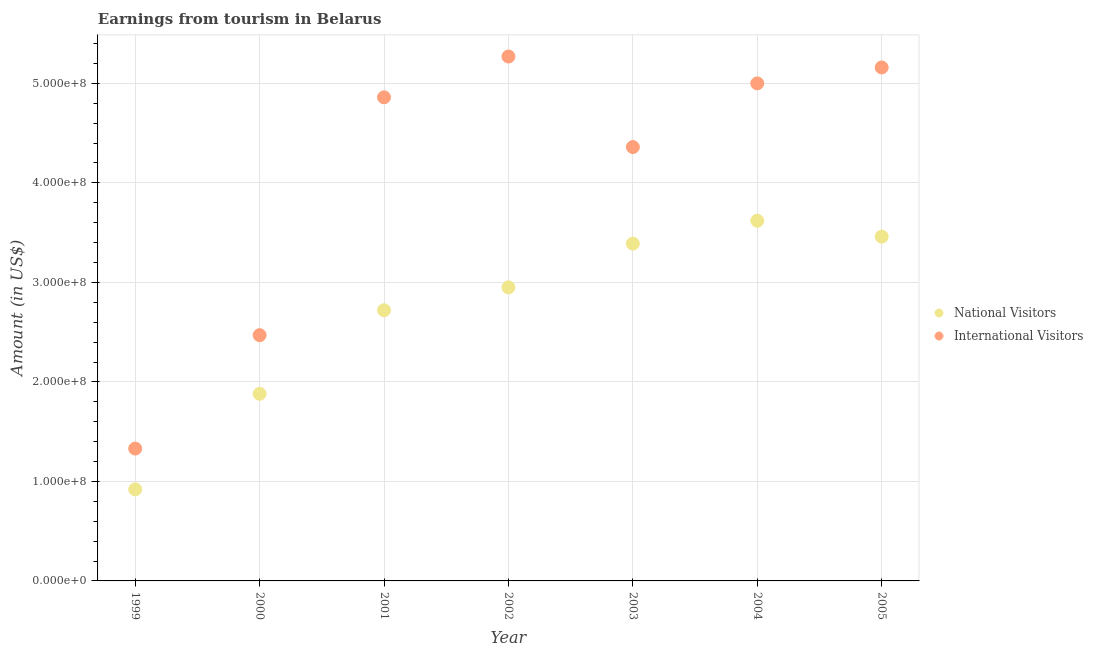How many different coloured dotlines are there?
Keep it short and to the point. 2. What is the amount earned from international visitors in 2005?
Offer a very short reply. 5.16e+08. Across all years, what is the maximum amount earned from national visitors?
Offer a terse response. 3.62e+08. Across all years, what is the minimum amount earned from international visitors?
Your answer should be very brief. 1.33e+08. In which year was the amount earned from international visitors minimum?
Provide a succinct answer. 1999. What is the total amount earned from national visitors in the graph?
Give a very brief answer. 1.89e+09. What is the difference between the amount earned from national visitors in 2001 and that in 2004?
Give a very brief answer. -9.00e+07. What is the difference between the amount earned from national visitors in 1999 and the amount earned from international visitors in 2005?
Keep it short and to the point. -4.24e+08. What is the average amount earned from national visitors per year?
Make the answer very short. 2.71e+08. In the year 2005, what is the difference between the amount earned from international visitors and amount earned from national visitors?
Ensure brevity in your answer.  1.70e+08. What is the ratio of the amount earned from international visitors in 2000 to that in 2002?
Offer a terse response. 0.47. Is the amount earned from international visitors in 1999 less than that in 2001?
Your response must be concise. Yes. Is the difference between the amount earned from national visitors in 2000 and 2004 greater than the difference between the amount earned from international visitors in 2000 and 2004?
Your answer should be very brief. Yes. What is the difference between the highest and the second highest amount earned from national visitors?
Give a very brief answer. 1.60e+07. What is the difference between the highest and the lowest amount earned from international visitors?
Ensure brevity in your answer.  3.94e+08. In how many years, is the amount earned from national visitors greater than the average amount earned from national visitors taken over all years?
Offer a very short reply. 5. Is the sum of the amount earned from national visitors in 1999 and 2003 greater than the maximum amount earned from international visitors across all years?
Provide a succinct answer. No. Is the amount earned from international visitors strictly less than the amount earned from national visitors over the years?
Ensure brevity in your answer.  No. How many dotlines are there?
Offer a very short reply. 2. How many legend labels are there?
Your response must be concise. 2. What is the title of the graph?
Your response must be concise. Earnings from tourism in Belarus. What is the label or title of the X-axis?
Your answer should be very brief. Year. What is the Amount (in US$) in National Visitors in 1999?
Make the answer very short. 9.20e+07. What is the Amount (in US$) in International Visitors in 1999?
Ensure brevity in your answer.  1.33e+08. What is the Amount (in US$) in National Visitors in 2000?
Provide a succinct answer. 1.88e+08. What is the Amount (in US$) in International Visitors in 2000?
Offer a terse response. 2.47e+08. What is the Amount (in US$) in National Visitors in 2001?
Your response must be concise. 2.72e+08. What is the Amount (in US$) of International Visitors in 2001?
Make the answer very short. 4.86e+08. What is the Amount (in US$) in National Visitors in 2002?
Provide a short and direct response. 2.95e+08. What is the Amount (in US$) in International Visitors in 2002?
Your answer should be compact. 5.27e+08. What is the Amount (in US$) of National Visitors in 2003?
Provide a short and direct response. 3.39e+08. What is the Amount (in US$) in International Visitors in 2003?
Offer a terse response. 4.36e+08. What is the Amount (in US$) of National Visitors in 2004?
Provide a succinct answer. 3.62e+08. What is the Amount (in US$) of National Visitors in 2005?
Offer a very short reply. 3.46e+08. What is the Amount (in US$) of International Visitors in 2005?
Provide a succinct answer. 5.16e+08. Across all years, what is the maximum Amount (in US$) in National Visitors?
Offer a very short reply. 3.62e+08. Across all years, what is the maximum Amount (in US$) of International Visitors?
Your answer should be compact. 5.27e+08. Across all years, what is the minimum Amount (in US$) of National Visitors?
Your answer should be very brief. 9.20e+07. Across all years, what is the minimum Amount (in US$) of International Visitors?
Your response must be concise. 1.33e+08. What is the total Amount (in US$) of National Visitors in the graph?
Your answer should be compact. 1.89e+09. What is the total Amount (in US$) in International Visitors in the graph?
Your answer should be compact. 2.84e+09. What is the difference between the Amount (in US$) in National Visitors in 1999 and that in 2000?
Make the answer very short. -9.60e+07. What is the difference between the Amount (in US$) in International Visitors in 1999 and that in 2000?
Provide a short and direct response. -1.14e+08. What is the difference between the Amount (in US$) in National Visitors in 1999 and that in 2001?
Provide a short and direct response. -1.80e+08. What is the difference between the Amount (in US$) in International Visitors in 1999 and that in 2001?
Ensure brevity in your answer.  -3.53e+08. What is the difference between the Amount (in US$) in National Visitors in 1999 and that in 2002?
Provide a succinct answer. -2.03e+08. What is the difference between the Amount (in US$) in International Visitors in 1999 and that in 2002?
Your answer should be very brief. -3.94e+08. What is the difference between the Amount (in US$) in National Visitors in 1999 and that in 2003?
Your response must be concise. -2.47e+08. What is the difference between the Amount (in US$) in International Visitors in 1999 and that in 2003?
Make the answer very short. -3.03e+08. What is the difference between the Amount (in US$) of National Visitors in 1999 and that in 2004?
Provide a short and direct response. -2.70e+08. What is the difference between the Amount (in US$) of International Visitors in 1999 and that in 2004?
Ensure brevity in your answer.  -3.67e+08. What is the difference between the Amount (in US$) of National Visitors in 1999 and that in 2005?
Ensure brevity in your answer.  -2.54e+08. What is the difference between the Amount (in US$) in International Visitors in 1999 and that in 2005?
Your answer should be very brief. -3.83e+08. What is the difference between the Amount (in US$) in National Visitors in 2000 and that in 2001?
Offer a very short reply. -8.40e+07. What is the difference between the Amount (in US$) in International Visitors in 2000 and that in 2001?
Provide a short and direct response. -2.39e+08. What is the difference between the Amount (in US$) in National Visitors in 2000 and that in 2002?
Offer a very short reply. -1.07e+08. What is the difference between the Amount (in US$) of International Visitors in 2000 and that in 2002?
Your answer should be compact. -2.80e+08. What is the difference between the Amount (in US$) of National Visitors in 2000 and that in 2003?
Keep it short and to the point. -1.51e+08. What is the difference between the Amount (in US$) in International Visitors in 2000 and that in 2003?
Offer a very short reply. -1.89e+08. What is the difference between the Amount (in US$) of National Visitors in 2000 and that in 2004?
Ensure brevity in your answer.  -1.74e+08. What is the difference between the Amount (in US$) of International Visitors in 2000 and that in 2004?
Offer a very short reply. -2.53e+08. What is the difference between the Amount (in US$) of National Visitors in 2000 and that in 2005?
Your answer should be very brief. -1.58e+08. What is the difference between the Amount (in US$) in International Visitors in 2000 and that in 2005?
Offer a terse response. -2.69e+08. What is the difference between the Amount (in US$) in National Visitors in 2001 and that in 2002?
Your response must be concise. -2.30e+07. What is the difference between the Amount (in US$) in International Visitors in 2001 and that in 2002?
Provide a succinct answer. -4.10e+07. What is the difference between the Amount (in US$) of National Visitors in 2001 and that in 2003?
Keep it short and to the point. -6.70e+07. What is the difference between the Amount (in US$) of National Visitors in 2001 and that in 2004?
Keep it short and to the point. -9.00e+07. What is the difference between the Amount (in US$) of International Visitors in 2001 and that in 2004?
Keep it short and to the point. -1.40e+07. What is the difference between the Amount (in US$) in National Visitors in 2001 and that in 2005?
Keep it short and to the point. -7.40e+07. What is the difference between the Amount (in US$) in International Visitors in 2001 and that in 2005?
Keep it short and to the point. -3.00e+07. What is the difference between the Amount (in US$) in National Visitors in 2002 and that in 2003?
Your answer should be very brief. -4.40e+07. What is the difference between the Amount (in US$) of International Visitors in 2002 and that in 2003?
Give a very brief answer. 9.10e+07. What is the difference between the Amount (in US$) of National Visitors in 2002 and that in 2004?
Your response must be concise. -6.70e+07. What is the difference between the Amount (in US$) in International Visitors in 2002 and that in 2004?
Offer a terse response. 2.70e+07. What is the difference between the Amount (in US$) in National Visitors in 2002 and that in 2005?
Your answer should be very brief. -5.10e+07. What is the difference between the Amount (in US$) in International Visitors in 2002 and that in 2005?
Offer a very short reply. 1.10e+07. What is the difference between the Amount (in US$) of National Visitors in 2003 and that in 2004?
Ensure brevity in your answer.  -2.30e+07. What is the difference between the Amount (in US$) of International Visitors in 2003 and that in 2004?
Provide a succinct answer. -6.40e+07. What is the difference between the Amount (in US$) in National Visitors in 2003 and that in 2005?
Offer a terse response. -7.00e+06. What is the difference between the Amount (in US$) in International Visitors in 2003 and that in 2005?
Keep it short and to the point. -8.00e+07. What is the difference between the Amount (in US$) in National Visitors in 2004 and that in 2005?
Your response must be concise. 1.60e+07. What is the difference between the Amount (in US$) of International Visitors in 2004 and that in 2005?
Your answer should be compact. -1.60e+07. What is the difference between the Amount (in US$) of National Visitors in 1999 and the Amount (in US$) of International Visitors in 2000?
Your answer should be compact. -1.55e+08. What is the difference between the Amount (in US$) of National Visitors in 1999 and the Amount (in US$) of International Visitors in 2001?
Make the answer very short. -3.94e+08. What is the difference between the Amount (in US$) of National Visitors in 1999 and the Amount (in US$) of International Visitors in 2002?
Your response must be concise. -4.35e+08. What is the difference between the Amount (in US$) of National Visitors in 1999 and the Amount (in US$) of International Visitors in 2003?
Keep it short and to the point. -3.44e+08. What is the difference between the Amount (in US$) of National Visitors in 1999 and the Amount (in US$) of International Visitors in 2004?
Keep it short and to the point. -4.08e+08. What is the difference between the Amount (in US$) of National Visitors in 1999 and the Amount (in US$) of International Visitors in 2005?
Offer a terse response. -4.24e+08. What is the difference between the Amount (in US$) in National Visitors in 2000 and the Amount (in US$) in International Visitors in 2001?
Keep it short and to the point. -2.98e+08. What is the difference between the Amount (in US$) of National Visitors in 2000 and the Amount (in US$) of International Visitors in 2002?
Offer a terse response. -3.39e+08. What is the difference between the Amount (in US$) of National Visitors in 2000 and the Amount (in US$) of International Visitors in 2003?
Your answer should be compact. -2.48e+08. What is the difference between the Amount (in US$) in National Visitors in 2000 and the Amount (in US$) in International Visitors in 2004?
Offer a very short reply. -3.12e+08. What is the difference between the Amount (in US$) of National Visitors in 2000 and the Amount (in US$) of International Visitors in 2005?
Offer a very short reply. -3.28e+08. What is the difference between the Amount (in US$) of National Visitors in 2001 and the Amount (in US$) of International Visitors in 2002?
Offer a terse response. -2.55e+08. What is the difference between the Amount (in US$) in National Visitors in 2001 and the Amount (in US$) in International Visitors in 2003?
Provide a succinct answer. -1.64e+08. What is the difference between the Amount (in US$) in National Visitors in 2001 and the Amount (in US$) in International Visitors in 2004?
Give a very brief answer. -2.28e+08. What is the difference between the Amount (in US$) in National Visitors in 2001 and the Amount (in US$) in International Visitors in 2005?
Your answer should be compact. -2.44e+08. What is the difference between the Amount (in US$) of National Visitors in 2002 and the Amount (in US$) of International Visitors in 2003?
Offer a terse response. -1.41e+08. What is the difference between the Amount (in US$) in National Visitors in 2002 and the Amount (in US$) in International Visitors in 2004?
Make the answer very short. -2.05e+08. What is the difference between the Amount (in US$) of National Visitors in 2002 and the Amount (in US$) of International Visitors in 2005?
Your answer should be very brief. -2.21e+08. What is the difference between the Amount (in US$) of National Visitors in 2003 and the Amount (in US$) of International Visitors in 2004?
Offer a very short reply. -1.61e+08. What is the difference between the Amount (in US$) in National Visitors in 2003 and the Amount (in US$) in International Visitors in 2005?
Ensure brevity in your answer.  -1.77e+08. What is the difference between the Amount (in US$) in National Visitors in 2004 and the Amount (in US$) in International Visitors in 2005?
Ensure brevity in your answer.  -1.54e+08. What is the average Amount (in US$) of National Visitors per year?
Your answer should be compact. 2.71e+08. What is the average Amount (in US$) of International Visitors per year?
Give a very brief answer. 4.06e+08. In the year 1999, what is the difference between the Amount (in US$) of National Visitors and Amount (in US$) of International Visitors?
Your response must be concise. -4.10e+07. In the year 2000, what is the difference between the Amount (in US$) of National Visitors and Amount (in US$) of International Visitors?
Your response must be concise. -5.90e+07. In the year 2001, what is the difference between the Amount (in US$) in National Visitors and Amount (in US$) in International Visitors?
Keep it short and to the point. -2.14e+08. In the year 2002, what is the difference between the Amount (in US$) in National Visitors and Amount (in US$) in International Visitors?
Offer a very short reply. -2.32e+08. In the year 2003, what is the difference between the Amount (in US$) of National Visitors and Amount (in US$) of International Visitors?
Your response must be concise. -9.70e+07. In the year 2004, what is the difference between the Amount (in US$) of National Visitors and Amount (in US$) of International Visitors?
Provide a succinct answer. -1.38e+08. In the year 2005, what is the difference between the Amount (in US$) of National Visitors and Amount (in US$) of International Visitors?
Provide a short and direct response. -1.70e+08. What is the ratio of the Amount (in US$) in National Visitors in 1999 to that in 2000?
Offer a very short reply. 0.49. What is the ratio of the Amount (in US$) of International Visitors in 1999 to that in 2000?
Your answer should be very brief. 0.54. What is the ratio of the Amount (in US$) in National Visitors in 1999 to that in 2001?
Your answer should be very brief. 0.34. What is the ratio of the Amount (in US$) of International Visitors in 1999 to that in 2001?
Your response must be concise. 0.27. What is the ratio of the Amount (in US$) of National Visitors in 1999 to that in 2002?
Your answer should be very brief. 0.31. What is the ratio of the Amount (in US$) of International Visitors in 1999 to that in 2002?
Provide a short and direct response. 0.25. What is the ratio of the Amount (in US$) of National Visitors in 1999 to that in 2003?
Offer a terse response. 0.27. What is the ratio of the Amount (in US$) in International Visitors in 1999 to that in 2003?
Make the answer very short. 0.3. What is the ratio of the Amount (in US$) of National Visitors in 1999 to that in 2004?
Provide a succinct answer. 0.25. What is the ratio of the Amount (in US$) in International Visitors in 1999 to that in 2004?
Your response must be concise. 0.27. What is the ratio of the Amount (in US$) of National Visitors in 1999 to that in 2005?
Provide a succinct answer. 0.27. What is the ratio of the Amount (in US$) of International Visitors in 1999 to that in 2005?
Provide a succinct answer. 0.26. What is the ratio of the Amount (in US$) in National Visitors in 2000 to that in 2001?
Give a very brief answer. 0.69. What is the ratio of the Amount (in US$) of International Visitors in 2000 to that in 2001?
Make the answer very short. 0.51. What is the ratio of the Amount (in US$) of National Visitors in 2000 to that in 2002?
Give a very brief answer. 0.64. What is the ratio of the Amount (in US$) in International Visitors in 2000 to that in 2002?
Your answer should be compact. 0.47. What is the ratio of the Amount (in US$) of National Visitors in 2000 to that in 2003?
Make the answer very short. 0.55. What is the ratio of the Amount (in US$) of International Visitors in 2000 to that in 2003?
Keep it short and to the point. 0.57. What is the ratio of the Amount (in US$) in National Visitors in 2000 to that in 2004?
Your answer should be compact. 0.52. What is the ratio of the Amount (in US$) in International Visitors in 2000 to that in 2004?
Keep it short and to the point. 0.49. What is the ratio of the Amount (in US$) in National Visitors in 2000 to that in 2005?
Provide a short and direct response. 0.54. What is the ratio of the Amount (in US$) of International Visitors in 2000 to that in 2005?
Offer a very short reply. 0.48. What is the ratio of the Amount (in US$) of National Visitors in 2001 to that in 2002?
Keep it short and to the point. 0.92. What is the ratio of the Amount (in US$) in International Visitors in 2001 to that in 2002?
Your response must be concise. 0.92. What is the ratio of the Amount (in US$) in National Visitors in 2001 to that in 2003?
Your response must be concise. 0.8. What is the ratio of the Amount (in US$) in International Visitors in 2001 to that in 2003?
Ensure brevity in your answer.  1.11. What is the ratio of the Amount (in US$) of National Visitors in 2001 to that in 2004?
Keep it short and to the point. 0.75. What is the ratio of the Amount (in US$) in National Visitors in 2001 to that in 2005?
Ensure brevity in your answer.  0.79. What is the ratio of the Amount (in US$) of International Visitors in 2001 to that in 2005?
Your answer should be very brief. 0.94. What is the ratio of the Amount (in US$) of National Visitors in 2002 to that in 2003?
Keep it short and to the point. 0.87. What is the ratio of the Amount (in US$) in International Visitors in 2002 to that in 2003?
Give a very brief answer. 1.21. What is the ratio of the Amount (in US$) of National Visitors in 2002 to that in 2004?
Offer a terse response. 0.81. What is the ratio of the Amount (in US$) of International Visitors in 2002 to that in 2004?
Make the answer very short. 1.05. What is the ratio of the Amount (in US$) of National Visitors in 2002 to that in 2005?
Give a very brief answer. 0.85. What is the ratio of the Amount (in US$) of International Visitors in 2002 to that in 2005?
Offer a very short reply. 1.02. What is the ratio of the Amount (in US$) of National Visitors in 2003 to that in 2004?
Keep it short and to the point. 0.94. What is the ratio of the Amount (in US$) of International Visitors in 2003 to that in 2004?
Your answer should be compact. 0.87. What is the ratio of the Amount (in US$) in National Visitors in 2003 to that in 2005?
Make the answer very short. 0.98. What is the ratio of the Amount (in US$) in International Visitors in 2003 to that in 2005?
Provide a succinct answer. 0.84. What is the ratio of the Amount (in US$) of National Visitors in 2004 to that in 2005?
Provide a short and direct response. 1.05. What is the difference between the highest and the second highest Amount (in US$) in National Visitors?
Provide a succinct answer. 1.60e+07. What is the difference between the highest and the second highest Amount (in US$) of International Visitors?
Keep it short and to the point. 1.10e+07. What is the difference between the highest and the lowest Amount (in US$) in National Visitors?
Offer a terse response. 2.70e+08. What is the difference between the highest and the lowest Amount (in US$) in International Visitors?
Keep it short and to the point. 3.94e+08. 